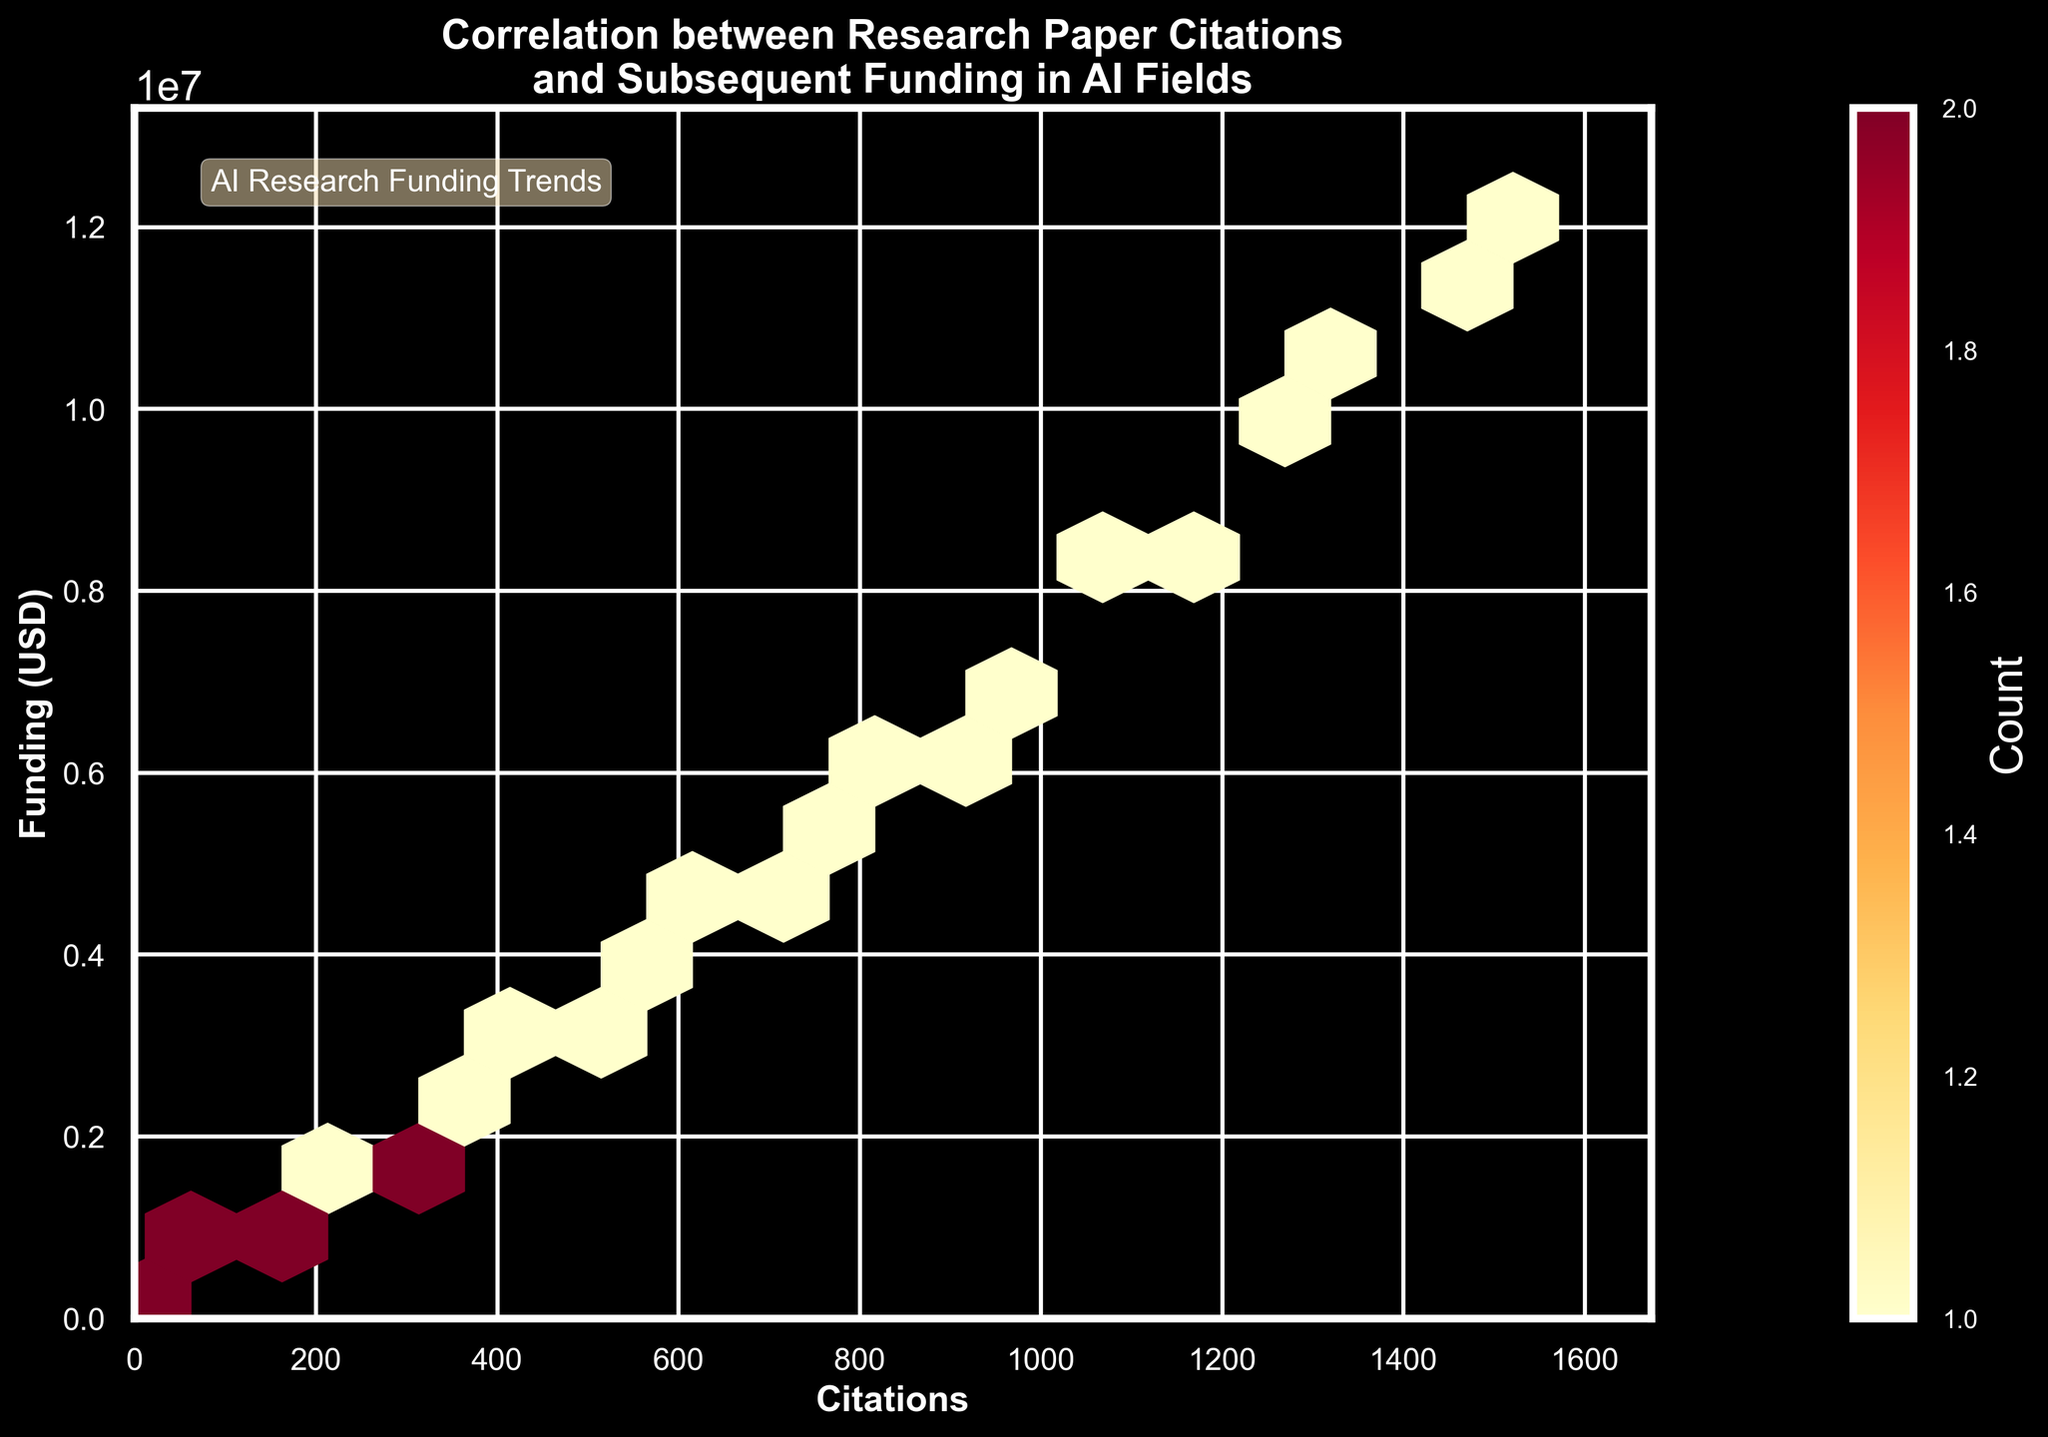What is the title of the plot? The title is generally located at the top of the plot, providing an overview of what the plot represents.
Answer: Correlation between Research Paper Citations and Subsequent Funding in AI Fields What are the labels of the x-axis and y-axis? The labels of axes are usually placed along the respective axes and indicate what each axis represents. The x-axis label is at the bottom and the y-axis label is at the left side of the plot.
Answer: Citations (x-axis), Funding (USD) (y-axis) What color is predominantly used in the plot for hexagons representing higher density of points? The color scheme in a hexbin plot shows varying densities; typically, brighter or darker shades indicate higher densities. In this plot, 'YlOrRd' is used, where areas of high density would be in darker reds/oranges.
Answer: Dark Red/Orange What range of citation counts does the plot cover? The range of citation counts is represented on the x-axis, bounded by the minimum and maximum citation values in the dataset. Looking at the x-axis limits will give this range.
Answer: 0 to approximately 1670 How can you identify the areas with the highest density of points in the plot? The highest density in a hexbin plot is identified by the color intensity. In this plot, hexagons with the darkest shades of red/orange represent the highest point density. Checking where the most intense colors cluster will locate these areas.
Answer: Darkest hexagons What does the color bar indicate? The color bar is often placed at the side of the plot and indicates what the colors in the hexagons represent, usually associating color gradients with numerical values. In this plot, the color bar helps understand the count of data points within each hexagon.
Answer: Count of points What do the ranges on the y-axis represent? The y-axis represents funding amounts in USD. By examining the tick labels aligned along the y-axis, we can determine the range of funding values.
Answer: 0 to approximately 14 million USD What can you infer about the correlation between citations and funding from the plot? In a hexbin plot, a positive correlation can be inferred if the hexagons form a pattern that ascends from left to right. Here, as citation counts increase, funding amounts also seem to increase, indicating a positive correlation.
Answer: Positive correlation Where is the highest concentration of citation counts and corresponding funding amounts? Finding the highest concentration involves looking for the densest cluster of hexagons, typically indicated by the darkest color. These clusters will tell where most data points lie both in terms of citation counts and funding.
Answer: Roughly between 0-250 citations and 0-1.5 million USD What does the text annotation "AI Research Funding Trends" signify in the plot? Text annotations in a plot add explanations or highlight notable information. Here, this text, found at the top-left inside the plot, likely notes the context or importance of the trends depicted in the data.
Answer: Additional context on AI research funding trends 